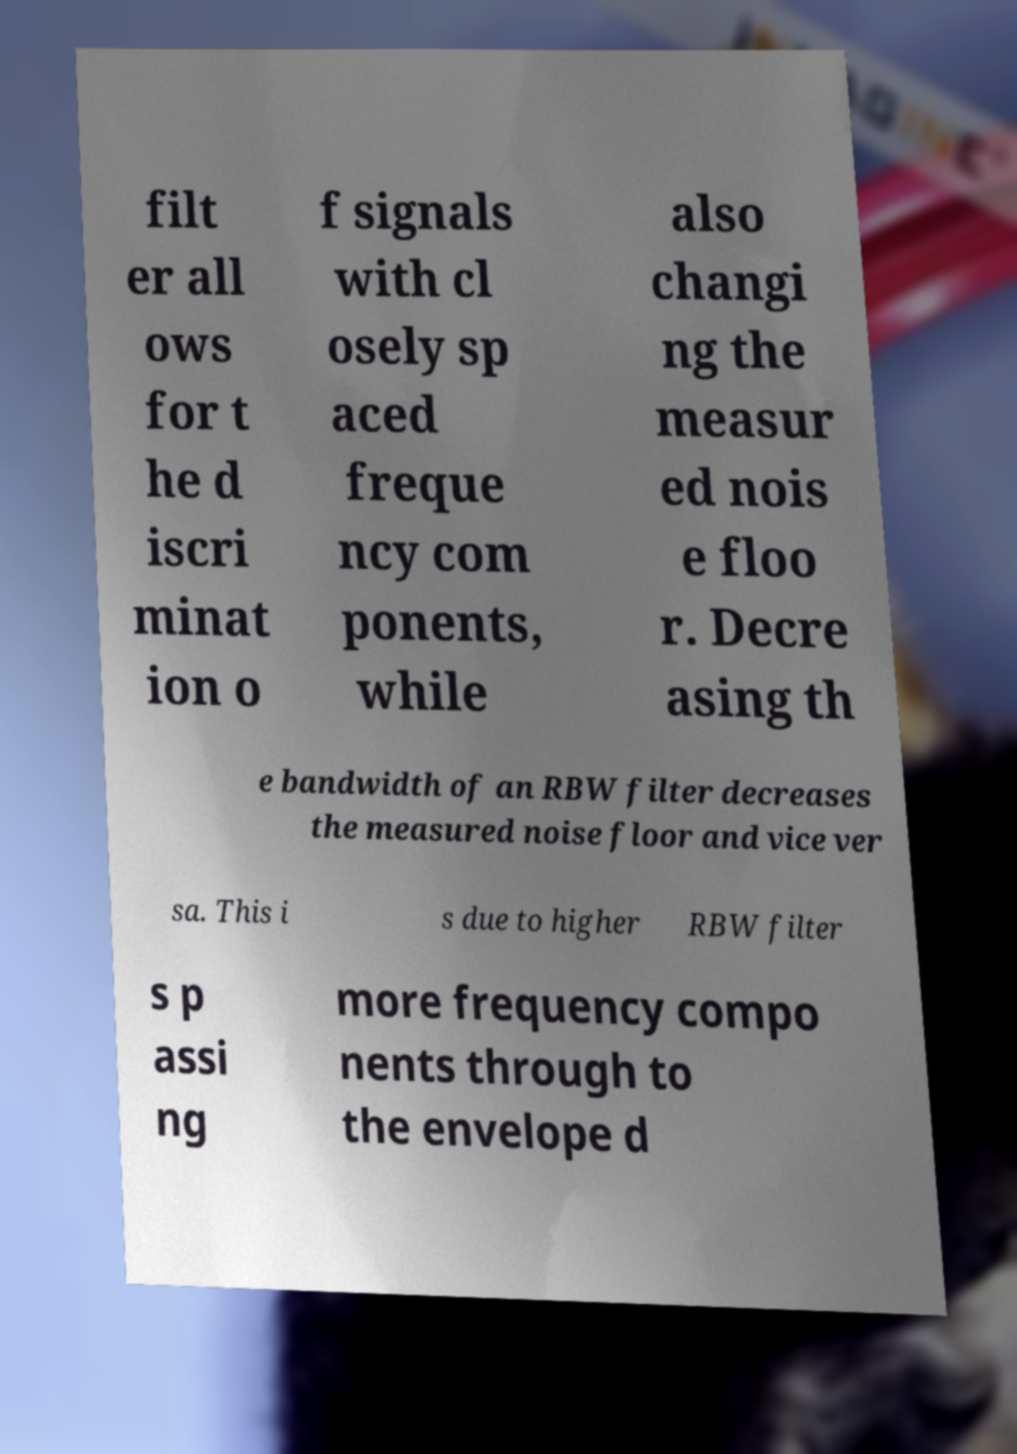Can you accurately transcribe the text from the provided image for me? filt er all ows for t he d iscri minat ion o f signals with cl osely sp aced freque ncy com ponents, while also changi ng the measur ed nois e floo r. Decre asing th e bandwidth of an RBW filter decreases the measured noise floor and vice ver sa. This i s due to higher RBW filter s p assi ng more frequency compo nents through to the envelope d 